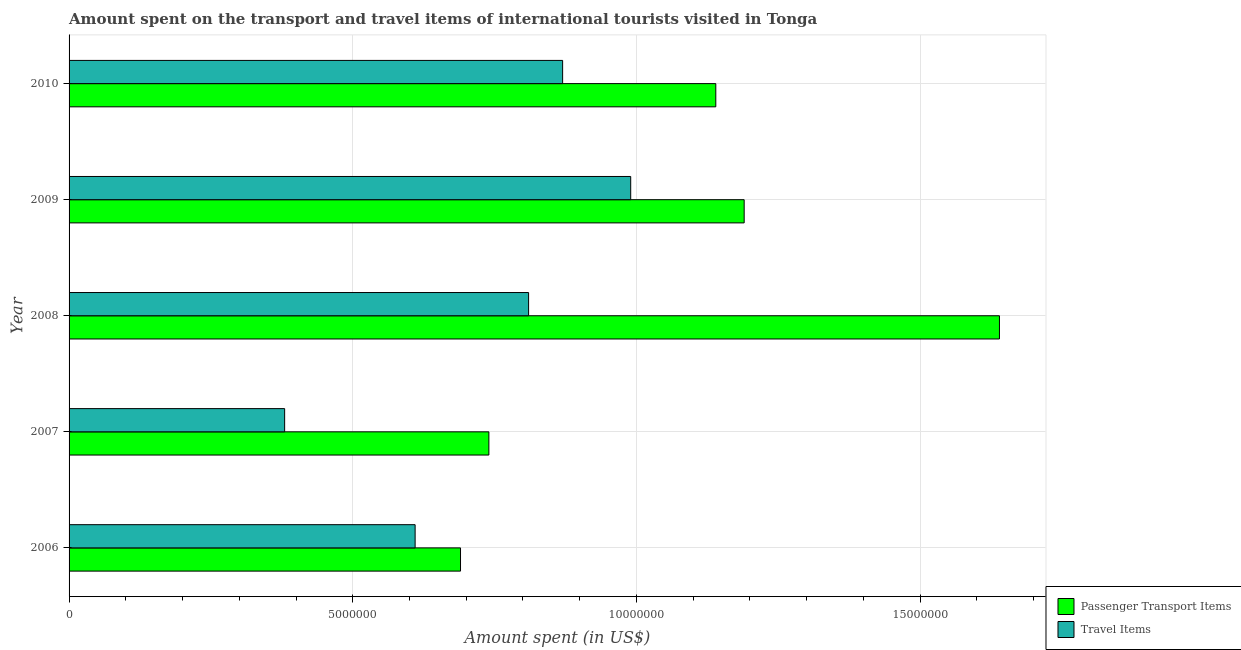How many different coloured bars are there?
Your answer should be compact. 2. Are the number of bars per tick equal to the number of legend labels?
Your answer should be compact. Yes. What is the label of the 3rd group of bars from the top?
Your answer should be compact. 2008. In how many cases, is the number of bars for a given year not equal to the number of legend labels?
Ensure brevity in your answer.  0. What is the amount spent in travel items in 2010?
Offer a terse response. 8.70e+06. Across all years, what is the maximum amount spent on passenger transport items?
Provide a short and direct response. 1.64e+07. Across all years, what is the minimum amount spent on passenger transport items?
Offer a terse response. 6.90e+06. In which year was the amount spent in travel items minimum?
Your answer should be very brief. 2007. What is the total amount spent in travel items in the graph?
Your answer should be very brief. 3.66e+07. What is the difference between the amount spent on passenger transport items in 2007 and that in 2009?
Your answer should be compact. -4.50e+06. What is the difference between the amount spent on passenger transport items in 2010 and the amount spent in travel items in 2007?
Ensure brevity in your answer.  7.60e+06. What is the average amount spent on passenger transport items per year?
Provide a succinct answer. 1.08e+07. In the year 2010, what is the difference between the amount spent on passenger transport items and amount spent in travel items?
Make the answer very short. 2.70e+06. In how many years, is the amount spent on passenger transport items greater than 9000000 US$?
Offer a terse response. 3. What is the ratio of the amount spent in travel items in 2007 to that in 2010?
Provide a short and direct response. 0.44. What is the difference between the highest and the second highest amount spent in travel items?
Your answer should be compact. 1.20e+06. What is the difference between the highest and the lowest amount spent on passenger transport items?
Provide a short and direct response. 9.50e+06. In how many years, is the amount spent on passenger transport items greater than the average amount spent on passenger transport items taken over all years?
Your answer should be very brief. 3. Is the sum of the amount spent on passenger transport items in 2008 and 2009 greater than the maximum amount spent in travel items across all years?
Your answer should be very brief. Yes. What does the 2nd bar from the top in 2006 represents?
Your response must be concise. Passenger Transport Items. What does the 1st bar from the bottom in 2010 represents?
Keep it short and to the point. Passenger Transport Items. How many bars are there?
Provide a succinct answer. 10. How many years are there in the graph?
Ensure brevity in your answer.  5. What is the difference between two consecutive major ticks on the X-axis?
Your answer should be very brief. 5.00e+06. Does the graph contain any zero values?
Provide a succinct answer. No. What is the title of the graph?
Your response must be concise. Amount spent on the transport and travel items of international tourists visited in Tonga. Does "IMF nonconcessional" appear as one of the legend labels in the graph?
Provide a short and direct response. No. What is the label or title of the X-axis?
Provide a short and direct response. Amount spent (in US$). What is the label or title of the Y-axis?
Offer a terse response. Year. What is the Amount spent (in US$) of Passenger Transport Items in 2006?
Provide a succinct answer. 6.90e+06. What is the Amount spent (in US$) in Travel Items in 2006?
Make the answer very short. 6.10e+06. What is the Amount spent (in US$) of Passenger Transport Items in 2007?
Offer a very short reply. 7.40e+06. What is the Amount spent (in US$) in Travel Items in 2007?
Offer a terse response. 3.80e+06. What is the Amount spent (in US$) in Passenger Transport Items in 2008?
Your answer should be compact. 1.64e+07. What is the Amount spent (in US$) of Travel Items in 2008?
Give a very brief answer. 8.10e+06. What is the Amount spent (in US$) of Passenger Transport Items in 2009?
Keep it short and to the point. 1.19e+07. What is the Amount spent (in US$) of Travel Items in 2009?
Your answer should be very brief. 9.90e+06. What is the Amount spent (in US$) of Passenger Transport Items in 2010?
Offer a terse response. 1.14e+07. What is the Amount spent (in US$) of Travel Items in 2010?
Your response must be concise. 8.70e+06. Across all years, what is the maximum Amount spent (in US$) in Passenger Transport Items?
Your answer should be compact. 1.64e+07. Across all years, what is the maximum Amount spent (in US$) of Travel Items?
Provide a succinct answer. 9.90e+06. Across all years, what is the minimum Amount spent (in US$) in Passenger Transport Items?
Ensure brevity in your answer.  6.90e+06. Across all years, what is the minimum Amount spent (in US$) in Travel Items?
Keep it short and to the point. 3.80e+06. What is the total Amount spent (in US$) in Passenger Transport Items in the graph?
Provide a short and direct response. 5.40e+07. What is the total Amount spent (in US$) of Travel Items in the graph?
Give a very brief answer. 3.66e+07. What is the difference between the Amount spent (in US$) of Passenger Transport Items in 2006 and that in 2007?
Your response must be concise. -5.00e+05. What is the difference between the Amount spent (in US$) in Travel Items in 2006 and that in 2007?
Make the answer very short. 2.30e+06. What is the difference between the Amount spent (in US$) of Passenger Transport Items in 2006 and that in 2008?
Your response must be concise. -9.50e+06. What is the difference between the Amount spent (in US$) in Passenger Transport Items in 2006 and that in 2009?
Your answer should be compact. -5.00e+06. What is the difference between the Amount spent (in US$) of Travel Items in 2006 and that in 2009?
Make the answer very short. -3.80e+06. What is the difference between the Amount spent (in US$) of Passenger Transport Items in 2006 and that in 2010?
Your answer should be compact. -4.50e+06. What is the difference between the Amount spent (in US$) of Travel Items in 2006 and that in 2010?
Make the answer very short. -2.60e+06. What is the difference between the Amount spent (in US$) in Passenger Transport Items in 2007 and that in 2008?
Keep it short and to the point. -9.00e+06. What is the difference between the Amount spent (in US$) of Travel Items in 2007 and that in 2008?
Your answer should be very brief. -4.30e+06. What is the difference between the Amount spent (in US$) of Passenger Transport Items in 2007 and that in 2009?
Keep it short and to the point. -4.50e+06. What is the difference between the Amount spent (in US$) of Travel Items in 2007 and that in 2009?
Your response must be concise. -6.10e+06. What is the difference between the Amount spent (in US$) in Travel Items in 2007 and that in 2010?
Offer a very short reply. -4.90e+06. What is the difference between the Amount spent (in US$) in Passenger Transport Items in 2008 and that in 2009?
Give a very brief answer. 4.50e+06. What is the difference between the Amount spent (in US$) in Travel Items in 2008 and that in 2009?
Your response must be concise. -1.80e+06. What is the difference between the Amount spent (in US$) of Travel Items in 2008 and that in 2010?
Your answer should be compact. -6.00e+05. What is the difference between the Amount spent (in US$) in Travel Items in 2009 and that in 2010?
Offer a terse response. 1.20e+06. What is the difference between the Amount spent (in US$) of Passenger Transport Items in 2006 and the Amount spent (in US$) of Travel Items in 2007?
Offer a terse response. 3.10e+06. What is the difference between the Amount spent (in US$) of Passenger Transport Items in 2006 and the Amount spent (in US$) of Travel Items in 2008?
Offer a terse response. -1.20e+06. What is the difference between the Amount spent (in US$) of Passenger Transport Items in 2006 and the Amount spent (in US$) of Travel Items in 2010?
Provide a short and direct response. -1.80e+06. What is the difference between the Amount spent (in US$) in Passenger Transport Items in 2007 and the Amount spent (in US$) in Travel Items in 2008?
Offer a very short reply. -7.00e+05. What is the difference between the Amount spent (in US$) of Passenger Transport Items in 2007 and the Amount spent (in US$) of Travel Items in 2009?
Give a very brief answer. -2.50e+06. What is the difference between the Amount spent (in US$) in Passenger Transport Items in 2007 and the Amount spent (in US$) in Travel Items in 2010?
Your answer should be very brief. -1.30e+06. What is the difference between the Amount spent (in US$) in Passenger Transport Items in 2008 and the Amount spent (in US$) in Travel Items in 2009?
Make the answer very short. 6.50e+06. What is the difference between the Amount spent (in US$) in Passenger Transport Items in 2008 and the Amount spent (in US$) in Travel Items in 2010?
Offer a very short reply. 7.70e+06. What is the difference between the Amount spent (in US$) in Passenger Transport Items in 2009 and the Amount spent (in US$) in Travel Items in 2010?
Offer a terse response. 3.20e+06. What is the average Amount spent (in US$) in Passenger Transport Items per year?
Offer a very short reply. 1.08e+07. What is the average Amount spent (in US$) of Travel Items per year?
Your answer should be very brief. 7.32e+06. In the year 2006, what is the difference between the Amount spent (in US$) of Passenger Transport Items and Amount spent (in US$) of Travel Items?
Your answer should be very brief. 8.00e+05. In the year 2007, what is the difference between the Amount spent (in US$) in Passenger Transport Items and Amount spent (in US$) in Travel Items?
Provide a succinct answer. 3.60e+06. In the year 2008, what is the difference between the Amount spent (in US$) of Passenger Transport Items and Amount spent (in US$) of Travel Items?
Offer a very short reply. 8.30e+06. In the year 2009, what is the difference between the Amount spent (in US$) of Passenger Transport Items and Amount spent (in US$) of Travel Items?
Keep it short and to the point. 2.00e+06. In the year 2010, what is the difference between the Amount spent (in US$) in Passenger Transport Items and Amount spent (in US$) in Travel Items?
Keep it short and to the point. 2.70e+06. What is the ratio of the Amount spent (in US$) of Passenger Transport Items in 2006 to that in 2007?
Ensure brevity in your answer.  0.93. What is the ratio of the Amount spent (in US$) in Travel Items in 2006 to that in 2007?
Provide a short and direct response. 1.61. What is the ratio of the Amount spent (in US$) of Passenger Transport Items in 2006 to that in 2008?
Ensure brevity in your answer.  0.42. What is the ratio of the Amount spent (in US$) of Travel Items in 2006 to that in 2008?
Your answer should be compact. 0.75. What is the ratio of the Amount spent (in US$) in Passenger Transport Items in 2006 to that in 2009?
Give a very brief answer. 0.58. What is the ratio of the Amount spent (in US$) of Travel Items in 2006 to that in 2009?
Your answer should be compact. 0.62. What is the ratio of the Amount spent (in US$) in Passenger Transport Items in 2006 to that in 2010?
Provide a short and direct response. 0.61. What is the ratio of the Amount spent (in US$) in Travel Items in 2006 to that in 2010?
Give a very brief answer. 0.7. What is the ratio of the Amount spent (in US$) of Passenger Transport Items in 2007 to that in 2008?
Offer a terse response. 0.45. What is the ratio of the Amount spent (in US$) in Travel Items in 2007 to that in 2008?
Your answer should be compact. 0.47. What is the ratio of the Amount spent (in US$) of Passenger Transport Items in 2007 to that in 2009?
Ensure brevity in your answer.  0.62. What is the ratio of the Amount spent (in US$) in Travel Items in 2007 to that in 2009?
Provide a succinct answer. 0.38. What is the ratio of the Amount spent (in US$) of Passenger Transport Items in 2007 to that in 2010?
Give a very brief answer. 0.65. What is the ratio of the Amount spent (in US$) in Travel Items in 2007 to that in 2010?
Ensure brevity in your answer.  0.44. What is the ratio of the Amount spent (in US$) in Passenger Transport Items in 2008 to that in 2009?
Keep it short and to the point. 1.38. What is the ratio of the Amount spent (in US$) in Travel Items in 2008 to that in 2009?
Your answer should be compact. 0.82. What is the ratio of the Amount spent (in US$) of Passenger Transport Items in 2008 to that in 2010?
Offer a very short reply. 1.44. What is the ratio of the Amount spent (in US$) in Passenger Transport Items in 2009 to that in 2010?
Your answer should be compact. 1.04. What is the ratio of the Amount spent (in US$) of Travel Items in 2009 to that in 2010?
Provide a short and direct response. 1.14. What is the difference between the highest and the second highest Amount spent (in US$) of Passenger Transport Items?
Your answer should be compact. 4.50e+06. What is the difference between the highest and the second highest Amount spent (in US$) in Travel Items?
Offer a very short reply. 1.20e+06. What is the difference between the highest and the lowest Amount spent (in US$) of Passenger Transport Items?
Offer a terse response. 9.50e+06. What is the difference between the highest and the lowest Amount spent (in US$) in Travel Items?
Ensure brevity in your answer.  6.10e+06. 